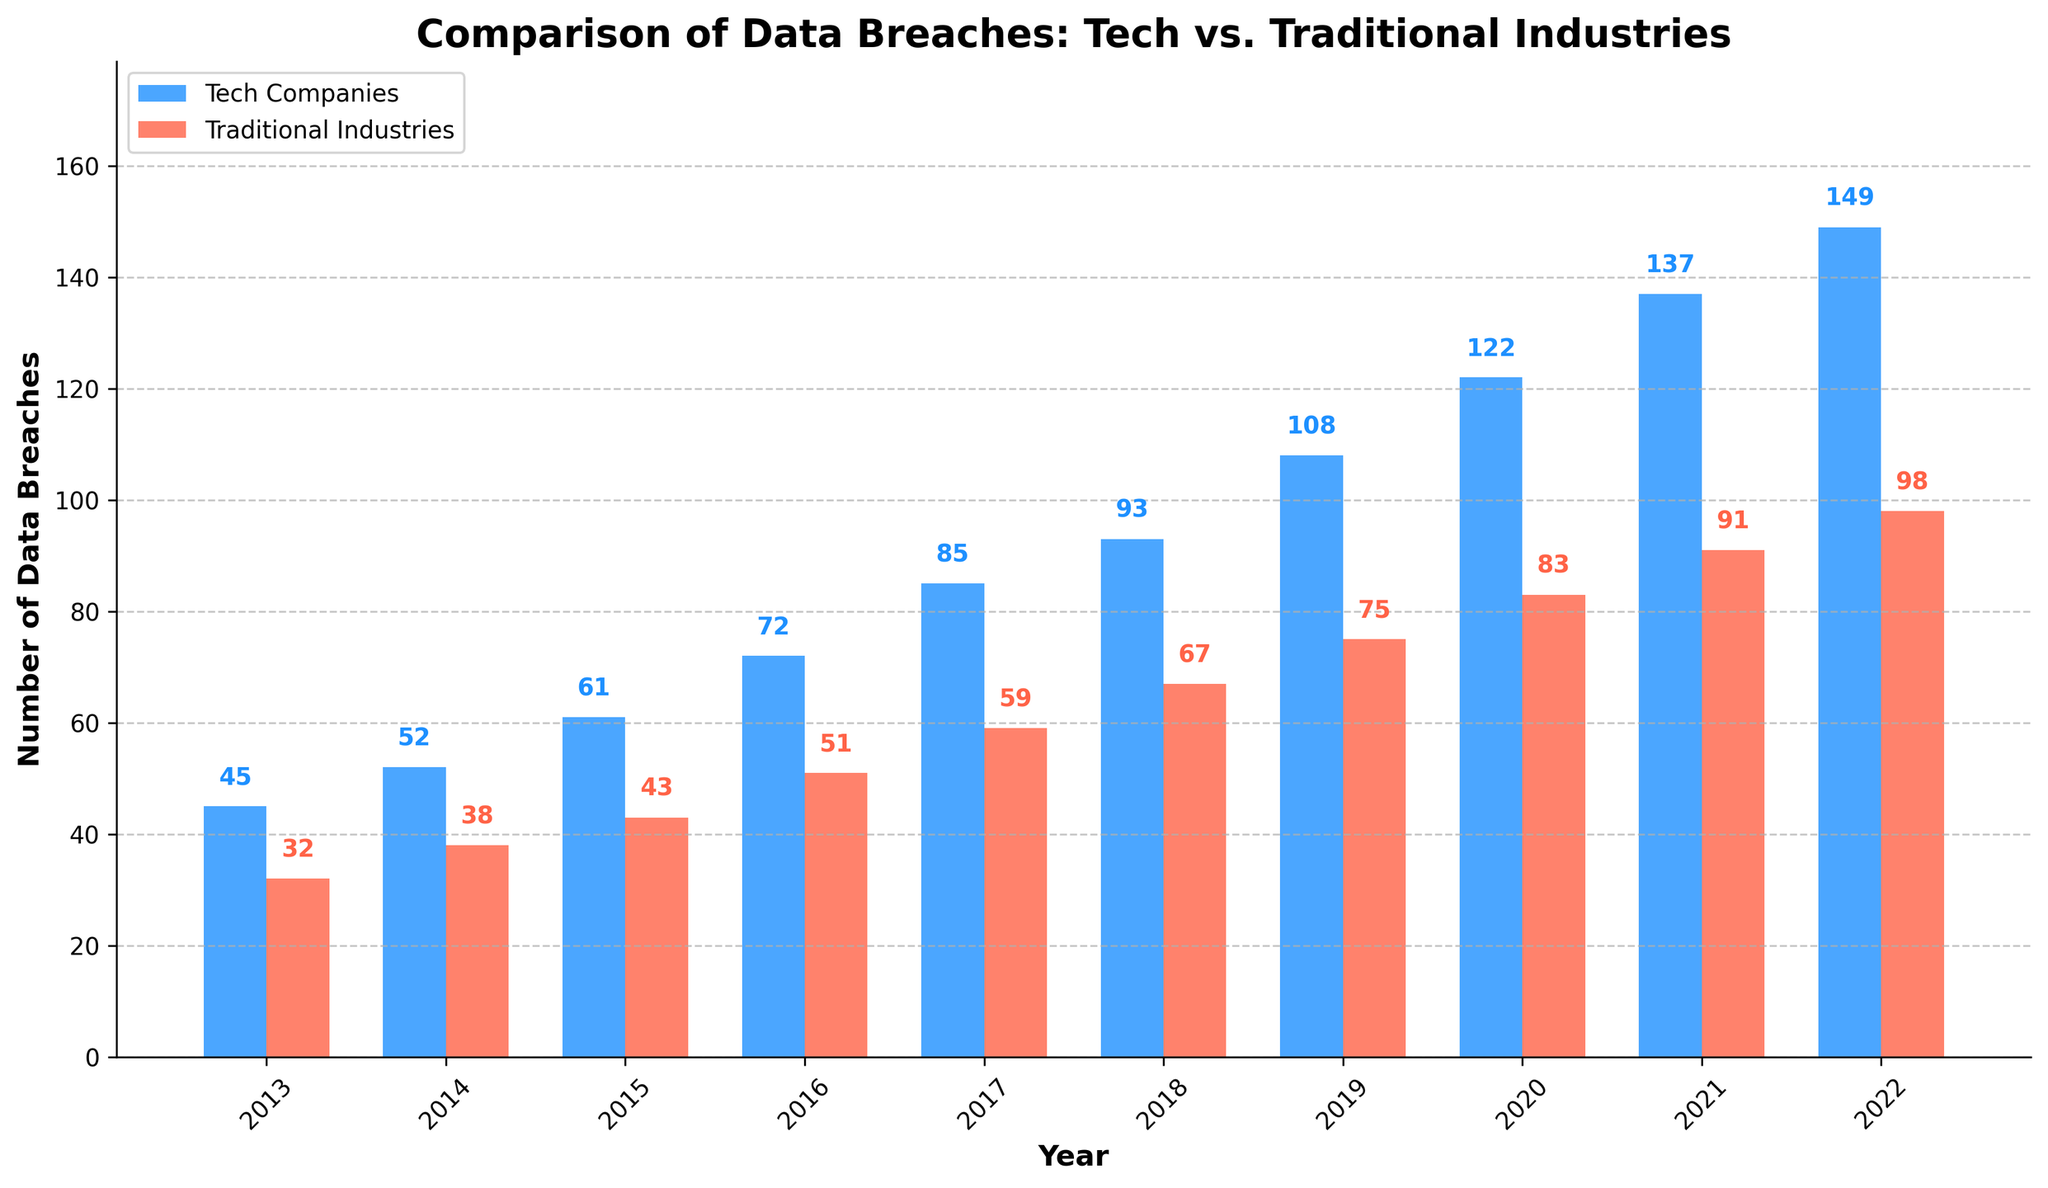which year had the highest number of data breaches in tech companies? Looking at the bar chart, the highest bar for tech companies is in 2022, indicating the highest number of data breaches that year.
Answer: 2022 how much did data breaches in tech companies increase from 2013 to 2022? To find the increase, subtract the number of breaches in 2013 from those in 2022: 149 - 45 = 104.
Answer: 104 compare the number of data breaches in traditional industries between 2018 and 2019. what is the difference? The number of breaches in traditional industries in 2018 was 67, and in 2019 it was 75. The difference is 75 - 67 = 8.
Answer: 8 what was the average number of data breaches in tech companies over the decade? Sum all the data breaches for each year in tech companies (45 + 52 + 61 + 72 + 85 + 93 + 108 + 122 + 137 + 149) and divide by the number of years (10). The total is 924, so the average is 924/10 = 92.4.
Answer: 92.4 compare 2020 data breaches. which industry had more breaches, and by how much? In 2020, tech companies had 122 breaches, and traditional industries had 83. The difference is 122 - 83 = 39, with tech companies leading.
Answer: tech companies by 39 what is the overall trend for data breaches in both tech companies and traditional industries from 2013 to 2022? Both tech companies and traditional industries have an upward trend in data breaches over the years. This is observed as the heights of the bars increase year over year for both categories.
Answer: upward trend what is the combined number of data breaches for both industries in 2017? Sum the number of breaches for tech companies (85) and traditional industries (59) in 2017: 85 + 59 = 144.
Answer: 144 which year showed the smallest difference in data breaches between tech companies and traditional industries? Calculate the differences for each year, then identify the smallest difference. Differences are: 13, 14, 18, 21, 26, 26, 33, 39, 46, and 51 respectively. Therefore, the smallest difference is 13 in 2013.
Answer: 2013 looking at the visual representation, which industry had a more consistent increase in data breaches over the years? By observing the bars, tech companies show a more consistent and steady increase each year compared to traditional industries, where the growth rate varies more.
Answer: tech companies 